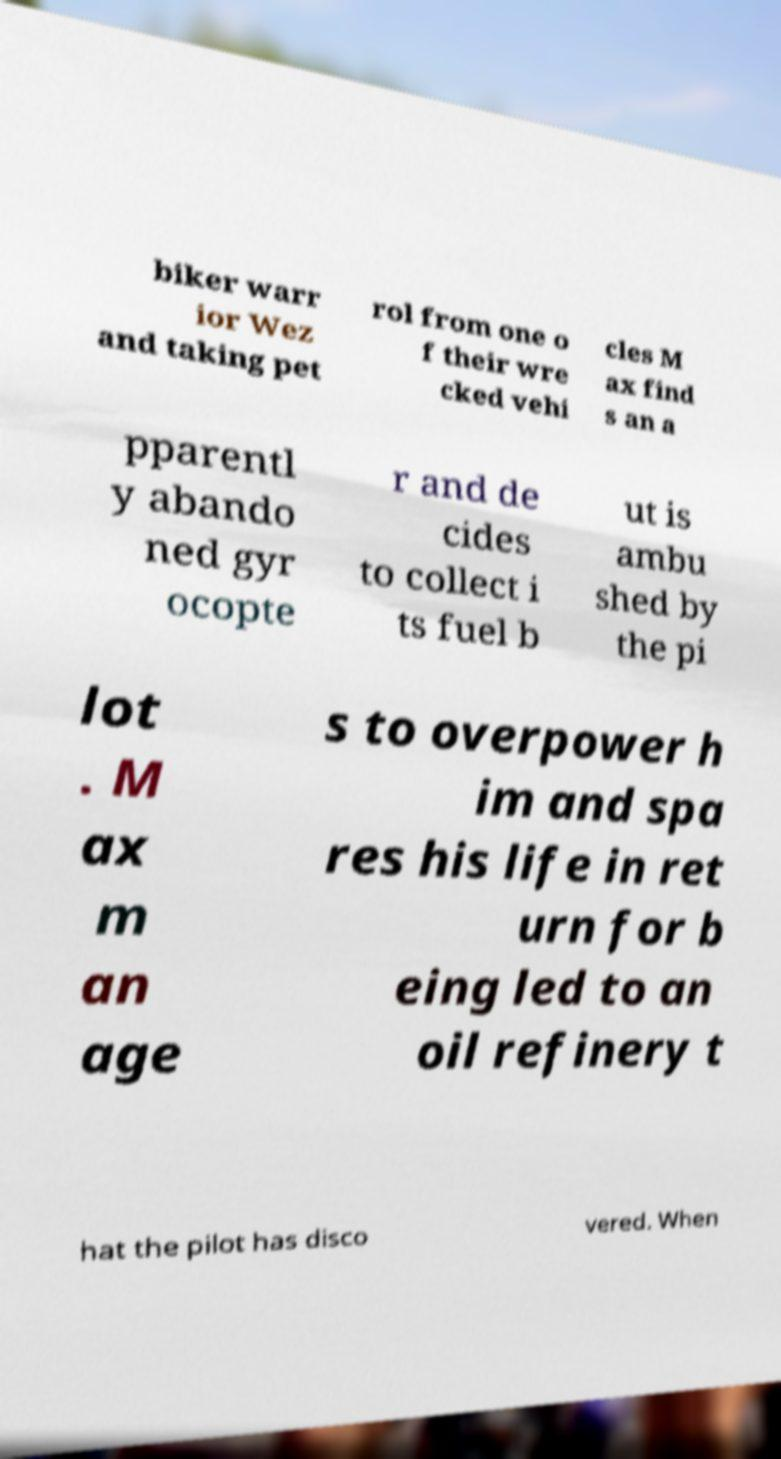Please read and relay the text visible in this image. What does it say? biker warr ior Wez and taking pet rol from one o f their wre cked vehi cles M ax find s an a pparentl y abando ned gyr ocopte r and de cides to collect i ts fuel b ut is ambu shed by the pi lot . M ax m an age s to overpower h im and spa res his life in ret urn for b eing led to an oil refinery t hat the pilot has disco vered. When 